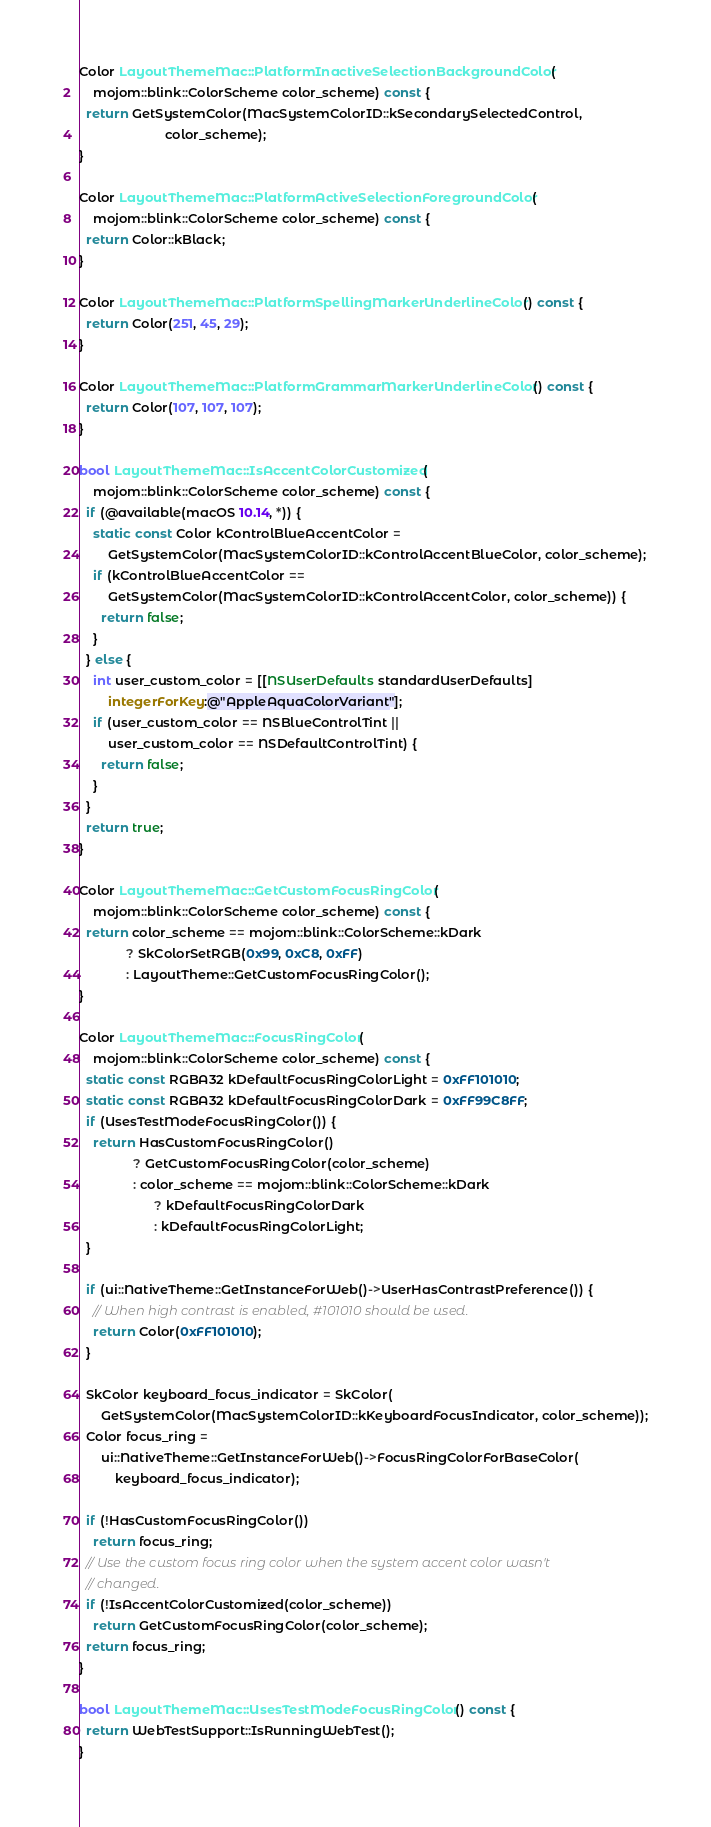Convert code to text. <code><loc_0><loc_0><loc_500><loc_500><_ObjectiveC_>Color LayoutThemeMac::PlatformInactiveSelectionBackgroundColor(
    mojom::blink::ColorScheme color_scheme) const {
  return GetSystemColor(MacSystemColorID::kSecondarySelectedControl,
                        color_scheme);
}

Color LayoutThemeMac::PlatformActiveSelectionForegroundColor(
    mojom::blink::ColorScheme color_scheme) const {
  return Color::kBlack;
}

Color LayoutThemeMac::PlatformSpellingMarkerUnderlineColor() const {
  return Color(251, 45, 29);
}

Color LayoutThemeMac::PlatformGrammarMarkerUnderlineColor() const {
  return Color(107, 107, 107);
}

bool LayoutThemeMac::IsAccentColorCustomized(
    mojom::blink::ColorScheme color_scheme) const {
  if (@available(macOS 10.14, *)) {
    static const Color kControlBlueAccentColor =
        GetSystemColor(MacSystemColorID::kControlAccentBlueColor, color_scheme);
    if (kControlBlueAccentColor ==
        GetSystemColor(MacSystemColorID::kControlAccentColor, color_scheme)) {
      return false;
    }
  } else {
    int user_custom_color = [[NSUserDefaults standardUserDefaults]
        integerForKey:@"AppleAquaColorVariant"];
    if (user_custom_color == NSBlueControlTint ||
        user_custom_color == NSDefaultControlTint) {
      return false;
    }
  }
  return true;
}

Color LayoutThemeMac::GetCustomFocusRingColor(
    mojom::blink::ColorScheme color_scheme) const {
  return color_scheme == mojom::blink::ColorScheme::kDark
             ? SkColorSetRGB(0x99, 0xC8, 0xFF)
             : LayoutTheme::GetCustomFocusRingColor();
}

Color LayoutThemeMac::FocusRingColor(
    mojom::blink::ColorScheme color_scheme) const {
  static const RGBA32 kDefaultFocusRingColorLight = 0xFF101010;
  static const RGBA32 kDefaultFocusRingColorDark = 0xFF99C8FF;
  if (UsesTestModeFocusRingColor()) {
    return HasCustomFocusRingColor()
               ? GetCustomFocusRingColor(color_scheme)
               : color_scheme == mojom::blink::ColorScheme::kDark
                     ? kDefaultFocusRingColorDark
                     : kDefaultFocusRingColorLight;
  }

  if (ui::NativeTheme::GetInstanceForWeb()->UserHasContrastPreference()) {
    // When high contrast is enabled, #101010 should be used.
    return Color(0xFF101010);
  }

  SkColor keyboard_focus_indicator = SkColor(
      GetSystemColor(MacSystemColorID::kKeyboardFocusIndicator, color_scheme));
  Color focus_ring =
      ui::NativeTheme::GetInstanceForWeb()->FocusRingColorForBaseColor(
          keyboard_focus_indicator);

  if (!HasCustomFocusRingColor())
    return focus_ring;
  // Use the custom focus ring color when the system accent color wasn't
  // changed.
  if (!IsAccentColorCustomized(color_scheme))
    return GetCustomFocusRingColor(color_scheme);
  return focus_ring;
}

bool LayoutThemeMac::UsesTestModeFocusRingColor() const {
  return WebTestSupport::IsRunningWebTest();
}
</code> 